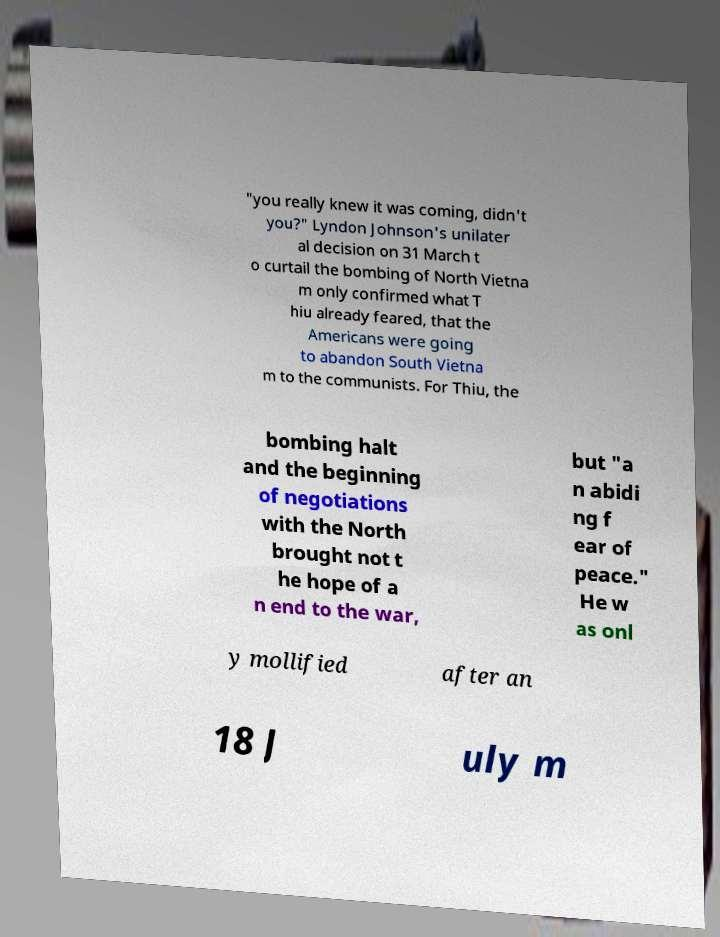Could you extract and type out the text from this image? "you really knew it was coming, didn't you?" Lyndon Johnson's unilater al decision on 31 March t o curtail the bombing of North Vietna m only confirmed what T hiu already feared, that the Americans were going to abandon South Vietna m to the communists. For Thiu, the bombing halt and the beginning of negotiations with the North brought not t he hope of a n end to the war, but "a n abidi ng f ear of peace." He w as onl y mollified after an 18 J uly m 